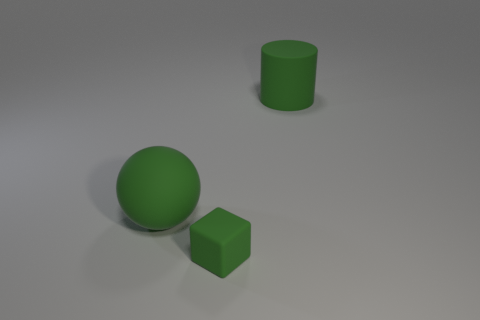Add 2 tiny green matte blocks. How many objects exist? 5 Add 1 large rubber balls. How many large rubber balls are left? 2 Add 3 tiny green objects. How many tiny green objects exist? 4 Subtract 1 green cubes. How many objects are left? 2 Subtract all cylinders. Subtract all large green cylinders. How many objects are left? 1 